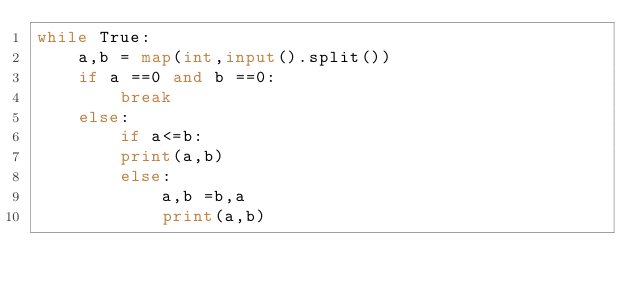<code> <loc_0><loc_0><loc_500><loc_500><_Python_>while True:
    a,b = map(int,input().split())
    if a ==0 and b ==0:
        break
    else:
        if a<=b:
        print(a,b)
        else:
            a,b =b,a
            print(a,b)
</code> 